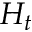<formula> <loc_0><loc_0><loc_500><loc_500>H _ { t }</formula> 